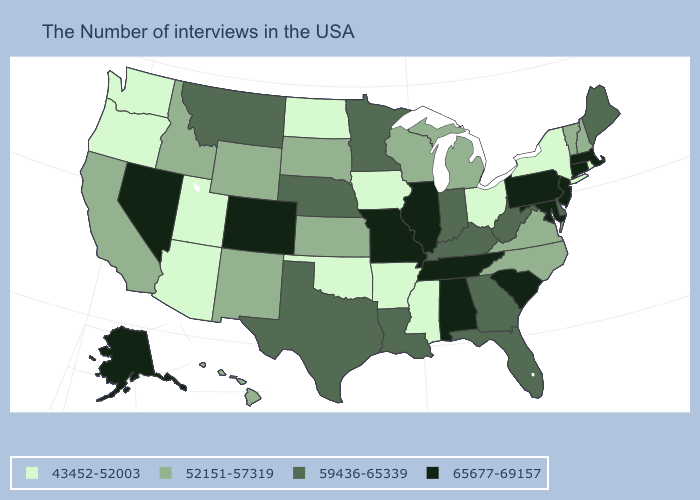Among the states that border New Mexico , which have the lowest value?
Be succinct. Oklahoma, Utah, Arizona. Among the states that border New Jersey , does Pennsylvania have the highest value?
Answer briefly. Yes. Does Alaska have the highest value in the West?
Give a very brief answer. Yes. What is the value of North Dakota?
Quick response, please. 43452-52003. Which states hav the highest value in the MidWest?
Quick response, please. Illinois, Missouri. Among the states that border Georgia , which have the lowest value?
Quick response, please. North Carolina. What is the value of Virginia?
Be succinct. 52151-57319. Does the first symbol in the legend represent the smallest category?
Be succinct. Yes. What is the value of North Dakota?
Keep it brief. 43452-52003. Name the states that have a value in the range 52151-57319?
Be succinct. New Hampshire, Vermont, Virginia, North Carolina, Michigan, Wisconsin, Kansas, South Dakota, Wyoming, New Mexico, Idaho, California, Hawaii. Name the states that have a value in the range 65677-69157?
Keep it brief. Massachusetts, Connecticut, New Jersey, Maryland, Pennsylvania, South Carolina, Alabama, Tennessee, Illinois, Missouri, Colorado, Nevada, Alaska. What is the value of North Dakota?
Be succinct. 43452-52003. Name the states that have a value in the range 65677-69157?
Short answer required. Massachusetts, Connecticut, New Jersey, Maryland, Pennsylvania, South Carolina, Alabama, Tennessee, Illinois, Missouri, Colorado, Nevada, Alaska. What is the value of Georgia?
Answer briefly. 59436-65339. Does the map have missing data?
Answer briefly. No. 